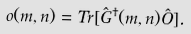<formula> <loc_0><loc_0><loc_500><loc_500>o ( m , n ) = T r [ \hat { G } ^ { \dagger } ( m , n ) \hat { O } ] .</formula> 